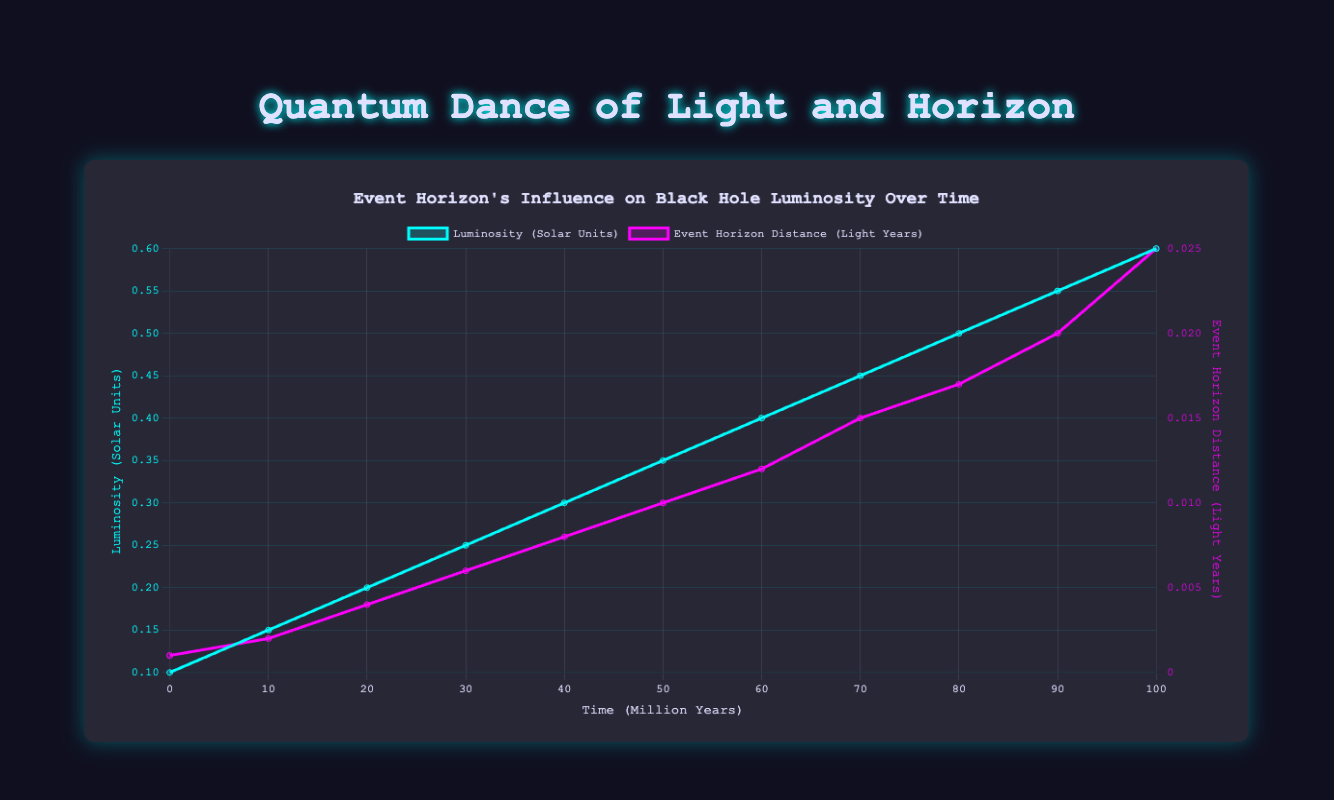What is the luminosity in solar units at the 30 million-year mark? The chart shows a line representing luminosity over time, and at the 30 million-year mark, the luminosity is directly aligned at the 0.25 solar units value.
Answer: 0.25 How does the event horizon distance in light years change between 60 and 80 million years? By looking at the line representing event horizon distance, at 60 million years, the distance is 0.012 light years, and at 80 million years, the distance is 0.017 light years. The change is 0.017 - 0.012 = 0.005 light years.
Answer: 0.005 Compare the luminosity values at 10 million years and 50 million years. Which one is higher and by how much? From the chart, the luminosity at 10 million years is 0.15 solar units, and at 50 million years it is 0.35 solar units. The difference is 0.35 - 0.15 = 0.20 solar units, so 50 million years has a higher luminosity by 0.20 solar units.
Answer: 0.20 (50 million years is higher) At what time period do both luminosity and event horizon distance reach their respective highest values? The chart shows that both lines reach their peaks at the 100 million-year mark, where luminosity is 0.6 solar units, and event horizon distance is 0.025 light years.
Answer: 100 million years What is the average luminosity value over the first 40 million years? The luminosity values for 0, 10, 20, 30, and 40 million years are 0.1, 0.15, 0.2, 0.25, and 0.3 respectively. Their sum is 0.1 + 0.15 + 0.2 + 0.25 + 0.3 = 1.00. The average is 1.00 / 5 = 0.20 solar units.
Answer: 0.20 When does the event horizon distance first reach or exceed 0.01 light years? The chart indicates that at the 50 million-year mark, the event horizon distance reaches 0.01 light years for the first time.
Answer: 50 million years How much does the luminosity increase from the starting point to the 100-million-year mark? Initially, the luminosity is 0.1 solar units, and at 100 million years, it is 0.6. The increase is 0.6 - 0.1 = 0.5 solar units.
Answer: 0.5 What is the relationship between the time period and the event horizon distance visually? The event horizon distance exhibits a form of steady, linear increase as time progresses, climbing continuously without any drops or fluctuations, from 0.001 light years to 0.025 light years by the end of the timeline.
Answer: Linear Increase 